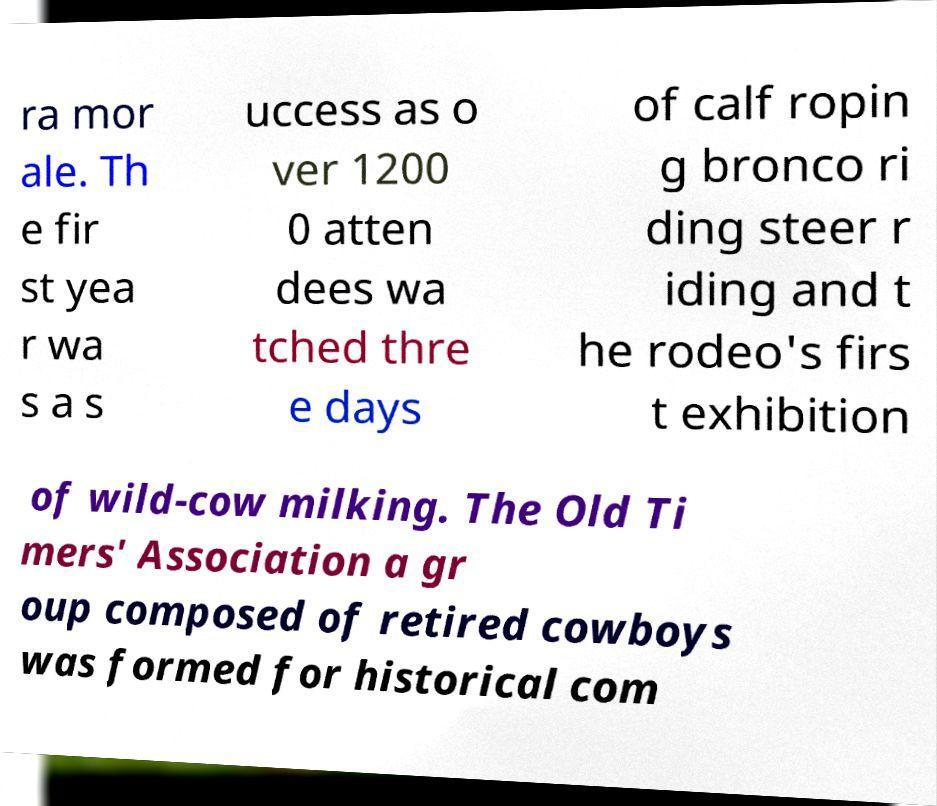There's text embedded in this image that I need extracted. Can you transcribe it verbatim? ra mor ale. Th e fir st yea r wa s a s uccess as o ver 1200 0 atten dees wa tched thre e days of calf ropin g bronco ri ding steer r iding and t he rodeo's firs t exhibition of wild-cow milking. The Old Ti mers' Association a gr oup composed of retired cowboys was formed for historical com 